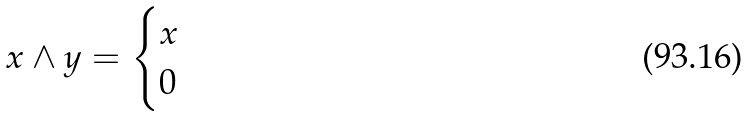Convert formula to latex. <formula><loc_0><loc_0><loc_500><loc_500>x \wedge y = \begin{cases} x & \\ 0 & \end{cases}</formula> 